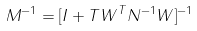<formula> <loc_0><loc_0><loc_500><loc_500>M ^ { - 1 } = [ I + T W ^ { T } N ^ { - 1 } W ] ^ { - 1 }</formula> 